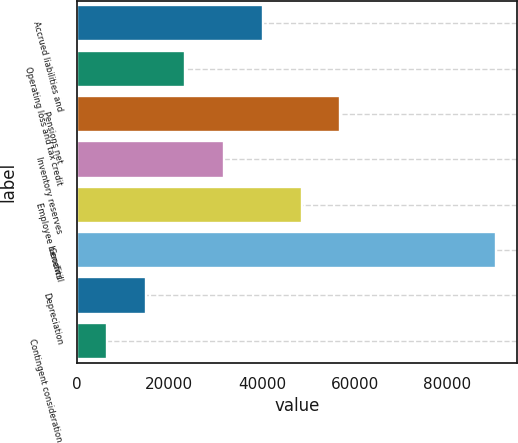<chart> <loc_0><loc_0><loc_500><loc_500><bar_chart><fcel>Accrued liabilities and<fcel>Operating loss and tax credit<fcel>Pensions net<fcel>Inventory reserves<fcel>Employee benefits<fcel>Goodwill<fcel>Depreciation<fcel>Contingent consideration<nl><fcel>40157<fcel>23374<fcel>56940<fcel>31765.5<fcel>48548.5<fcel>90506<fcel>14982.5<fcel>6591<nl></chart> 